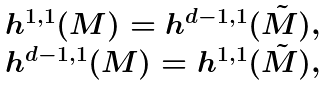<formula> <loc_0><loc_0><loc_500><loc_500>\begin{array} { c } h ^ { 1 , 1 } ( M ) = h ^ { d - 1 , 1 } ( \tilde { M } ) , \\ h ^ { d - 1 , 1 } ( M ) = h ^ { 1 , 1 } ( \tilde { M } ) , \end{array}</formula> 